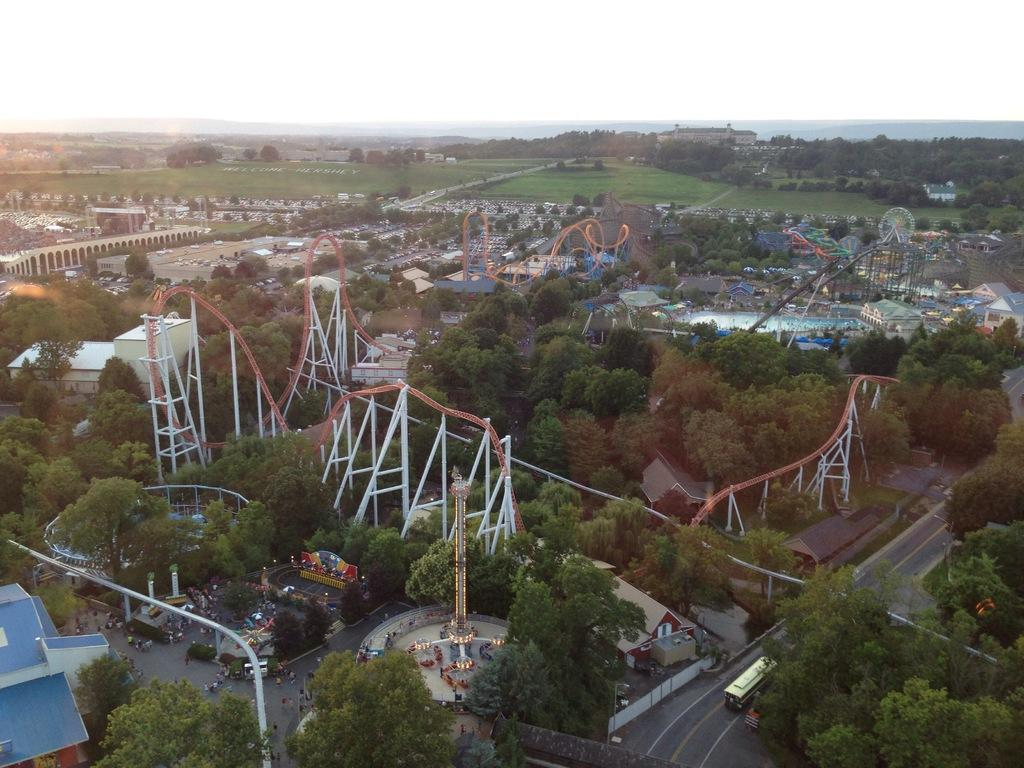What is located in the center of the image? There are rides in the center of the image. What type of natural elements can be seen in the image? There are trees and a mountain visible in the image. What can be seen in the background of the image? The sky and buildings are visible in the background of the image. What is at the bottom of the image? There is a road at the bottom of the image. What type of fruit is hanging from the trees in the image? There is no fruit visible on the trees in the image. What material is the sponge used for cleaning the rides in the image? There is no sponge present in the image, and the rides are not being cleaned. 